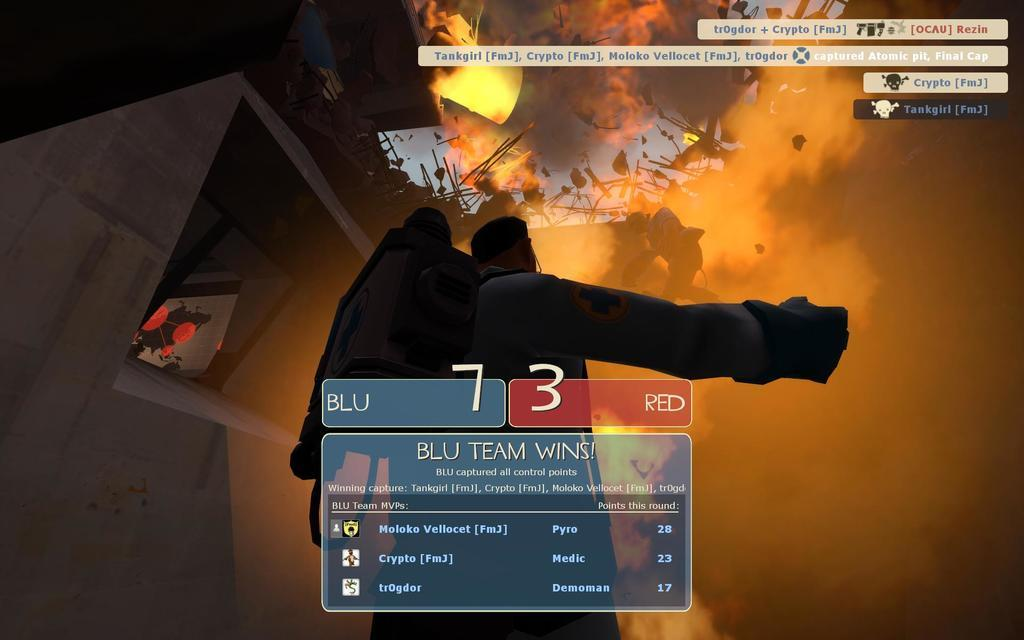Provide a one-sentence caption for the provided image. A game screen reading "BLU TEAM WINS" with scores of 7 for BLU team and 3 for RED team. 